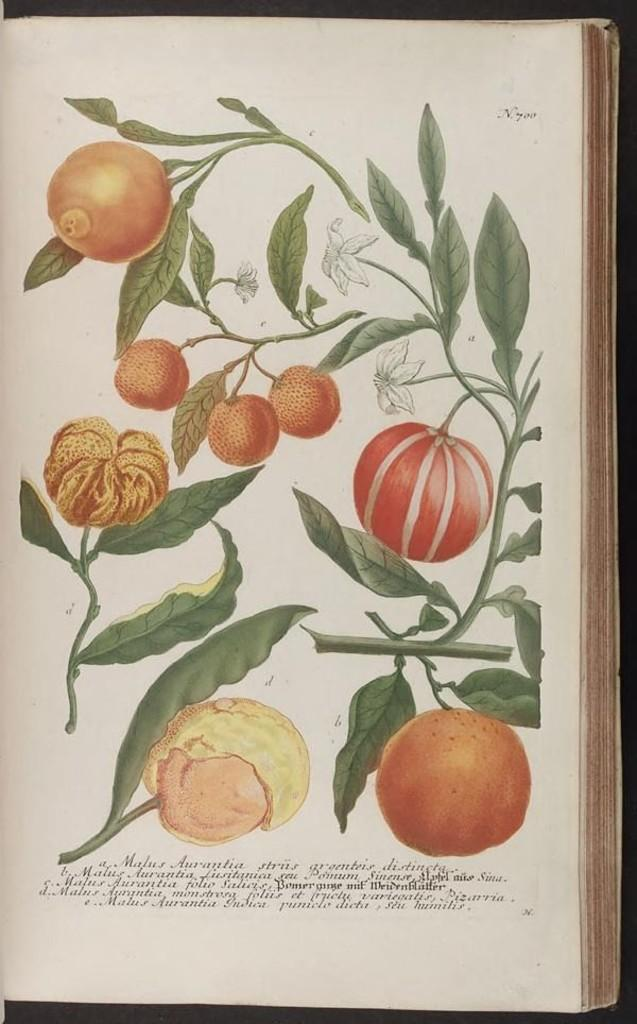What type of plant can be seen in the image? There is a plant with fruit in the image. What other object is present in the image? There is a book in the image. Reasoning: Let' Let's think step by step in order to produce the conversation. We start by identifying the main subjects in the image, which are the plant with fruit and the book. We then formulate questions that focus on the characteristics of these subjects, ensuring that each question can be answered definitively with the information given. We avoid yes/no questions and ensure that the language is simple and clear. Absurd Question/Answer: How many pigs are visible in the image? There are no pigs present in the image. What subject is the person teaching in the image? There is no person teaching in the image. Can you describe the cat's behavior in the image? There is no cat present in the image. What type of cat is sitting on the book in the image? There is no cat present in the image. What subject is the person teaching in the image? There is no person teaching in the image. How many pigs are visible in the image? There are no pigs present in the image. 